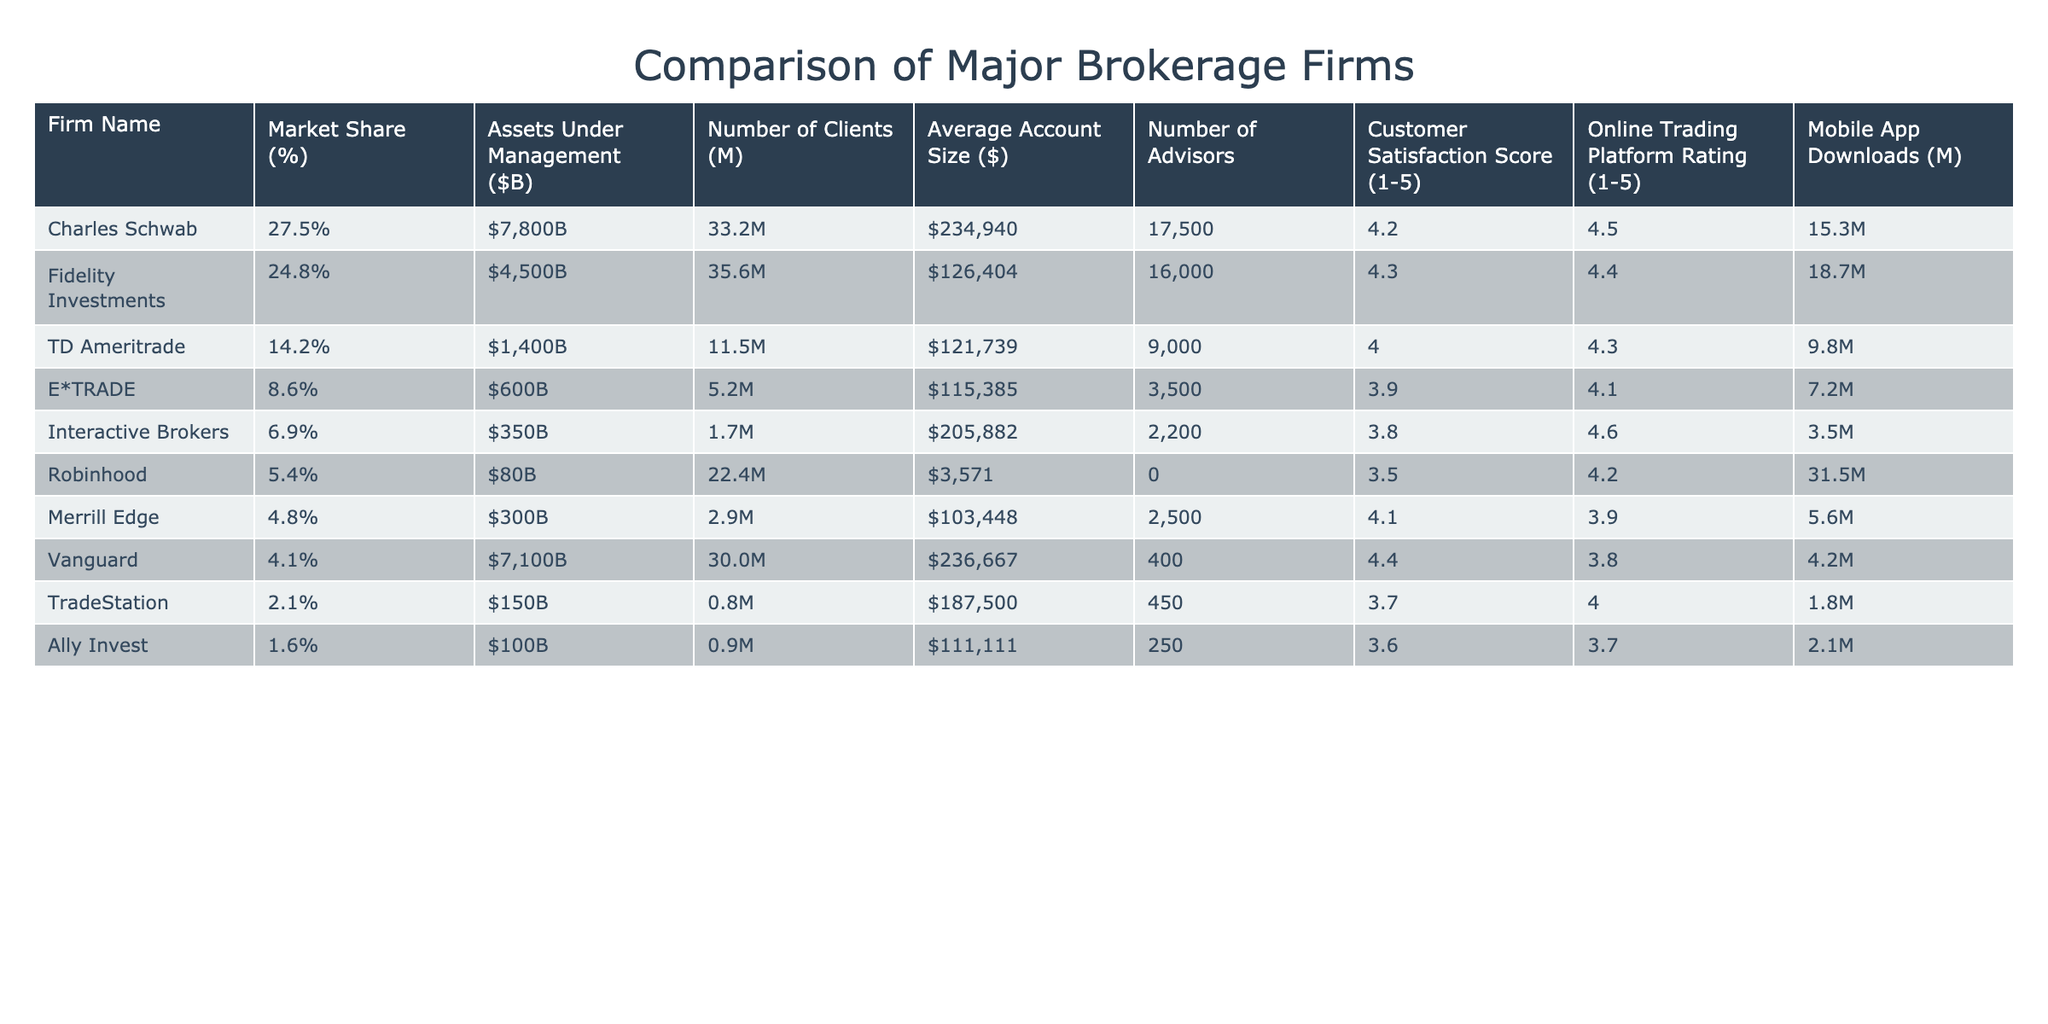What firm has the highest market share? The firm with the highest market share can be found in the first column under "Market Share (%)". Charles Schwab is listed with a market share of 27.5%, which is the largest in the table.
Answer: Charles Schwab What is the average customer satisfaction score among these firms? To find the average customer satisfaction score, we sum up the scores (4.2 + 4.3 + 4.0 + 3.9 + 3.8 + 3.5 + 4.1 + 4.4 + 3.6) = 30.8. There are 9 firms, so we divide by 9, giving us an average of 3.42.
Answer: 3.4 Which firm has the most assets under management? By looking at the "Assets Under Management ($B)" column, we see that Charles Schwab has the highest amount at $7800B, compared to other firms in the list.
Answer: Charles Schwab Is Robinhood the firm with the highest number of clients? In the "Number of Clients (M)" column, Robinhood shows 22.4 million clients, which is the highest compared to all other firms.
Answer: Yes What is the difference in average account size between Vanguard and E*TRADE? Finding the average account sizes, Vanguard is $236,667 and E*TRADE is $115,385. The difference is calculated as $236,667 - $115,385 = $121,282.
Answer: $121,282 Do more mobile app downloads correlate with higher customer satisfaction scores? Looking at the data, Robinhood has the most app downloads (31.5M) but a lower customer satisfaction score (3.5). In contrast, Fidelity has fewer downloads (18.7M) yet a higher satisfaction score (4.3). This indicates no clear correlation.
Answer: No Which firm has the fewest advisors and what is their satisfaction score? Interactive Brokers has the fewest advisors at 2,200, and their customer satisfaction score is 3.8.
Answer: 3.8 What is the combined market share of the top three firms? The top three firms are Charles Schwab (27.5%), Fidelity Investments (24.8%), and TD Ameritrade (14.2%). Adding these gives us 27.5 + 24.8 + 14.2 = 66.5%.
Answer: 66.5% How does the online trading platform rating of TD Ameritrade compare to that of E*TRADE? TD Ameritrade has a rating of 4.3 while E*TRADE has a rating of 4.1. Comparing these, TD Ameritrade has a higher rating than E*TRADE.
Answer: Higher 